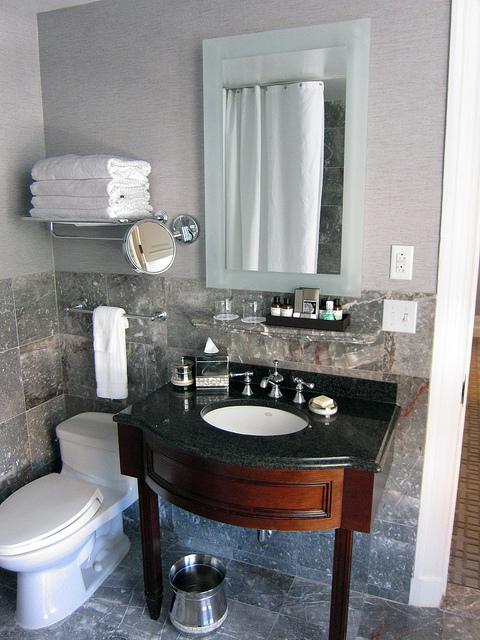Is the sink in this room black?
Be succinct. No. How many towels are folded above the toilet?
Be succinct. 4. Is there a medicine cabinet?
Quick response, please. Yes. 